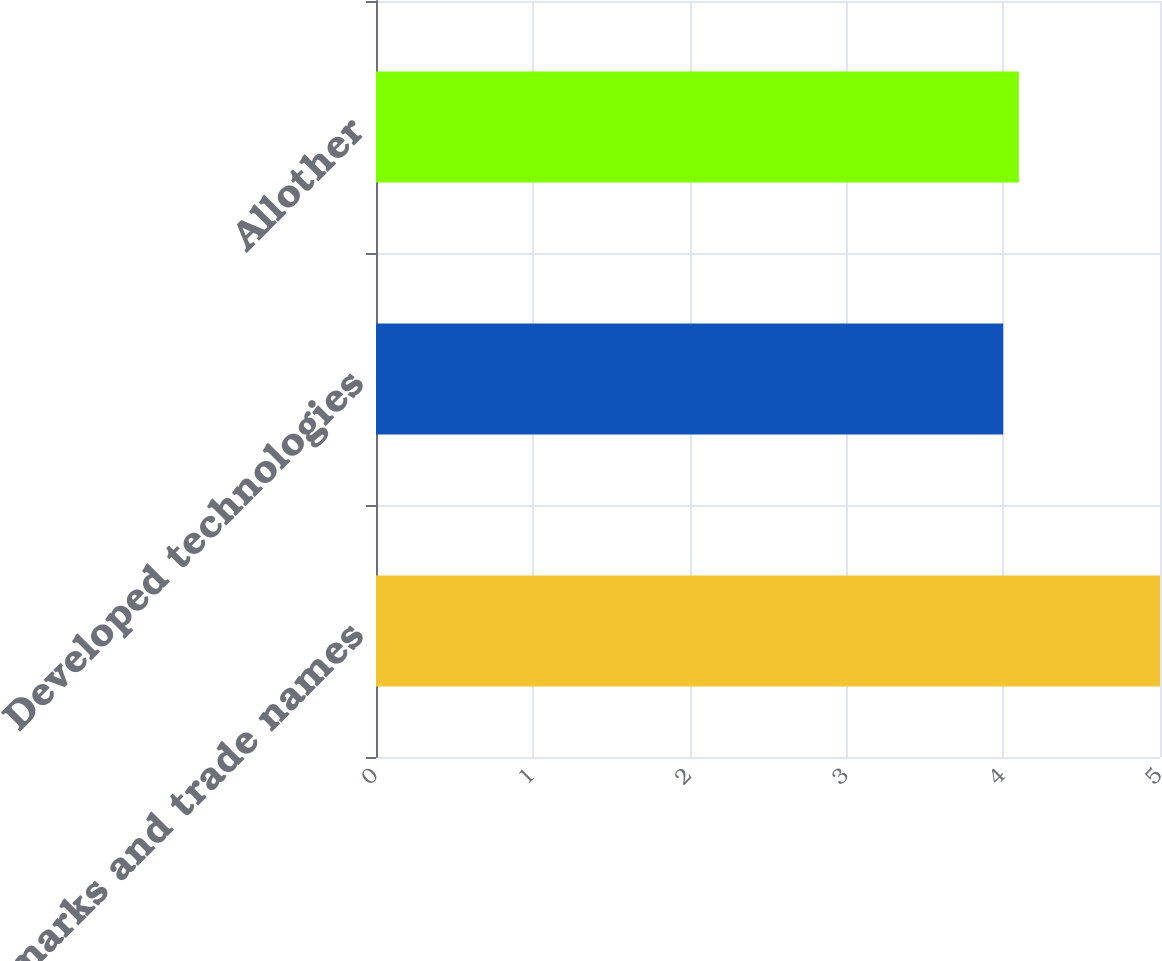Convert chart to OTSL. <chart><loc_0><loc_0><loc_500><loc_500><bar_chart><fcel>Trademarks and trade names<fcel>Developed technologies<fcel>Allother<nl><fcel>5<fcel>4<fcel>4.1<nl></chart> 